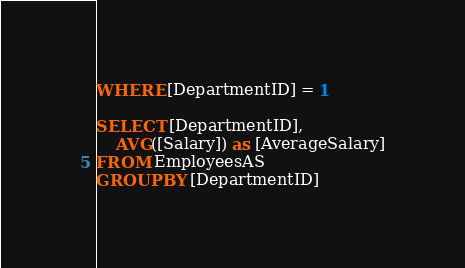Convert code to text. <code><loc_0><loc_0><loc_500><loc_500><_SQL_>WHERE [DepartmentID] = 1
 
SELECT [DepartmentID],
    AVG([Salary]) as [AverageSalary]
FROM EmployeesAS
GROUP BY [DepartmentID]</code> 